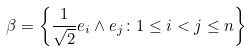Convert formula to latex. <formula><loc_0><loc_0><loc_500><loc_500>\beta = \left \{ \frac { 1 } { \sqrt { 2 } } e _ { i } \wedge e _ { j } \colon 1 \leq i < j \leq n \right \}</formula> 